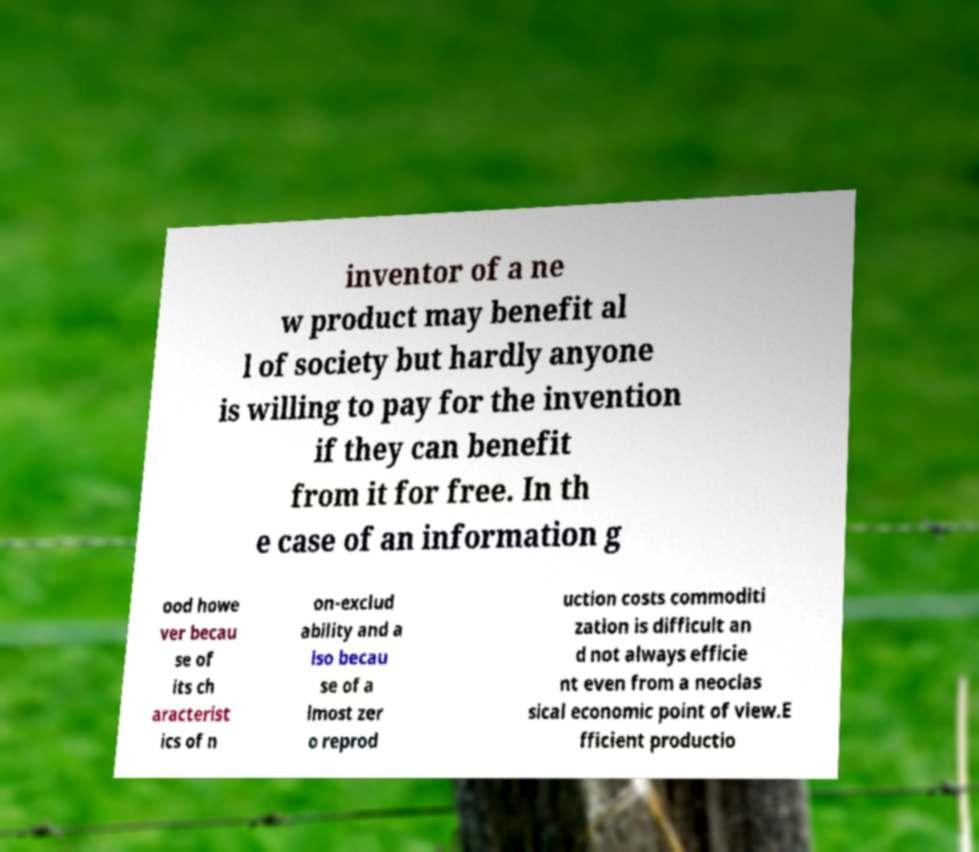I need the written content from this picture converted into text. Can you do that? inventor of a ne w product may benefit al l of society but hardly anyone is willing to pay for the invention if they can benefit from it for free. In th e case of an information g ood howe ver becau se of its ch aracterist ics of n on-exclud ability and a lso becau se of a lmost zer o reprod uction costs commoditi zation is difficult an d not always efficie nt even from a neoclas sical economic point of view.E fficient productio 